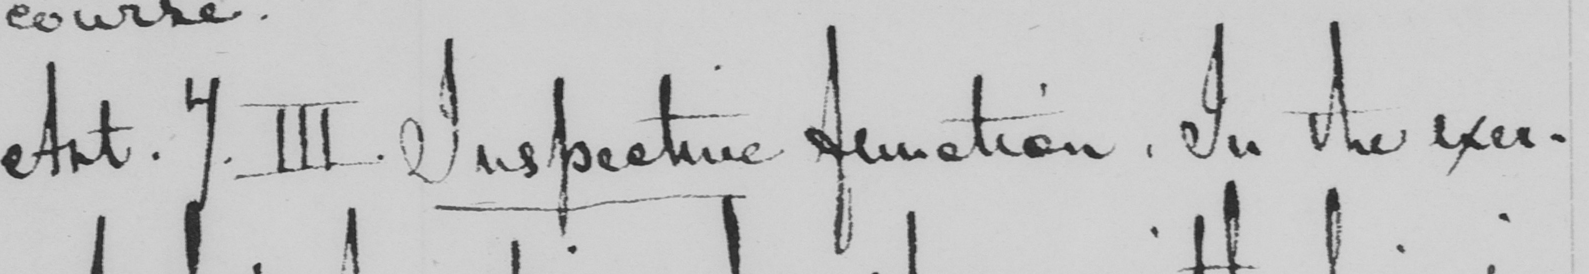What does this handwritten line say? Ant . 7.III . Inspective function . In the exer- 